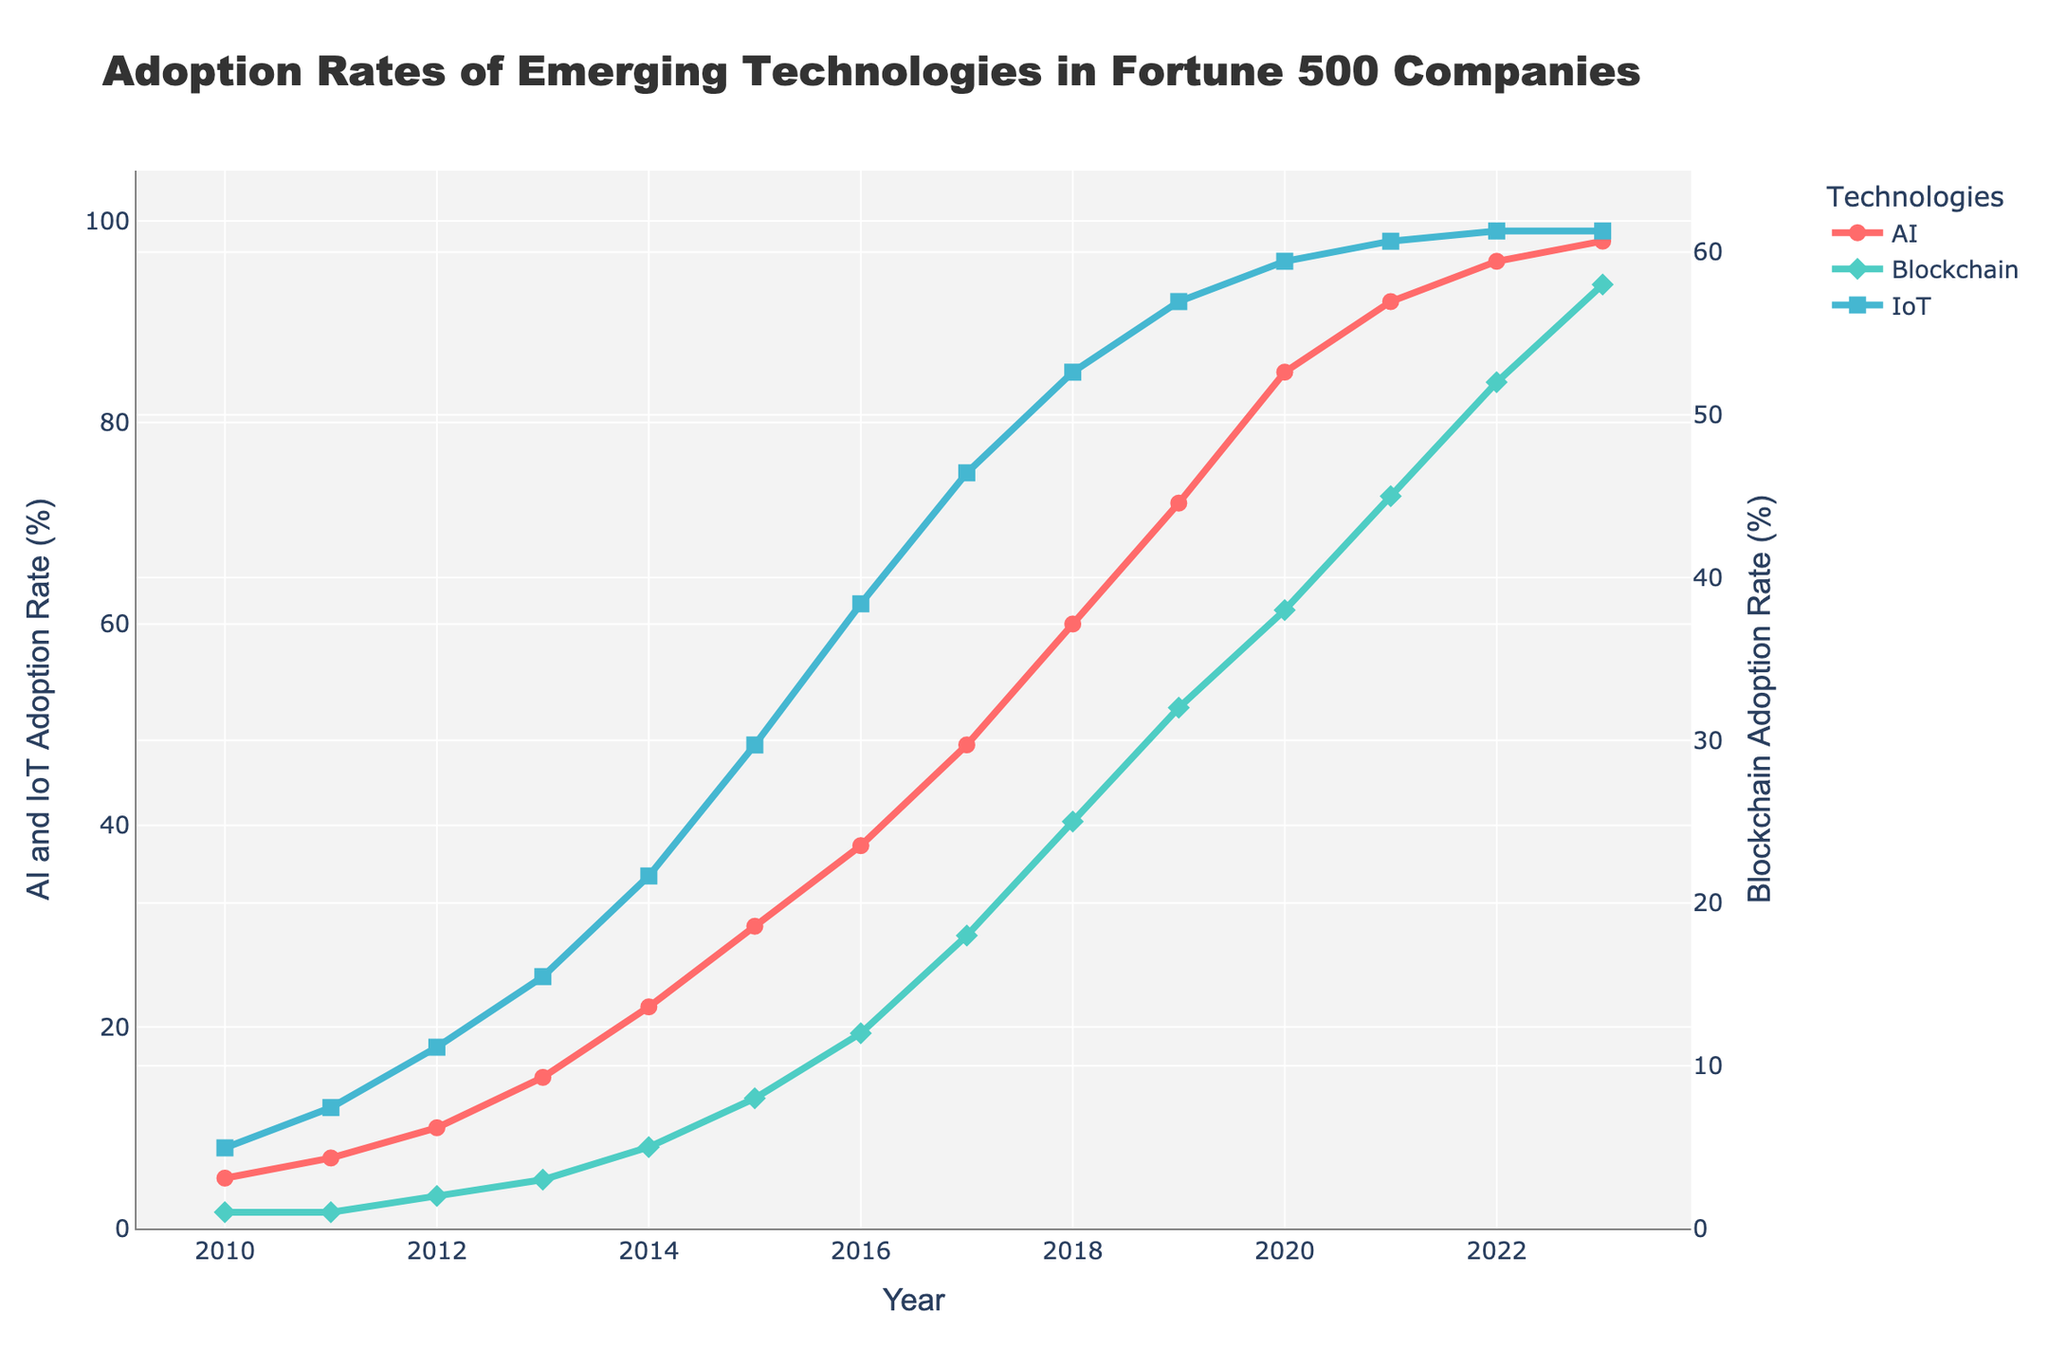What year did IoT adoption rate reach 50%? To find when the IoT adoption rate reached 50%, identify the year when the IoT line crosses the 50% mark. From the figure, it is clear that this happens in the year 2015.
Answer: 2015 Which technology had the highest adoption rate in 2023? Compare the y-values of AI, Blockchain, and IoT in 2023. The figure shows AI at 98%, Blockchain at 58%, and IoT at 99%. Hence, IoT has the highest adoption rate.
Answer: IoT Compare the adoption rates of AI and Blockchain in 2020. Look at the y-values for AI and Blockchain in 2020. The adoption rates are 85% for AI and 38% for Blockchain.
Answer: AI is higher In how many years did AI adoption exceed 50%? Identify the years when AI adoption is greater than 50% by examining the plot. This occurs from 2018 to 2023, totaling 6 years.
Answer: 6 years By how much did the adoption rate for Blockchain increase from 2015 to 2023? Find the difference in Blockchain adoption rates between 2015 and 2023. It increased from 8% in 2015 to 58% in 2023. The increase is 58% - 8% = 50%.
Answer: 50% When did the AI adoption rate first surpass the IoT adoption rate? Check when the AI line first crosses above the IoT line in the figure. This happens around the year 2017.
Answer: 2017 Which technology showed the most consistent year-over-year growth from 2010 to 2023? Assess the line slopes for AI, Blockchain, and IoT. While all show growth, AI and IoT have more consistent, steeper lines compared to Blockchain, especially in the mid years. AI shows the most consistent overall growth.
Answer: AI What is the combined adoption rate of AI and IoT in 2019? Add the adoption rates of AI and IoT in 2019. AI is at 72% and IoT at 92%, giving a combined rate of 72% + 92% = 164%.
Answer: 164% From 2016 to 2018, which technology had the largest increase in adoption rate? Calculate the difference in adoption rates for each technology from 2016 to 2018. AI increases from 38% to 60% (+22%), Blockchain from 12% to 25% (+13%), and IoT from 62% to 85% (+23%). IoT had the largest increase.
Answer: IoT What visual element differentiates the Blockchain data points from others? Observe the markers used in the plot. Blockchain is represented by diamond-shaped markers, while AI and IoT use circle and square markers respectively.
Answer: Diamond markers 